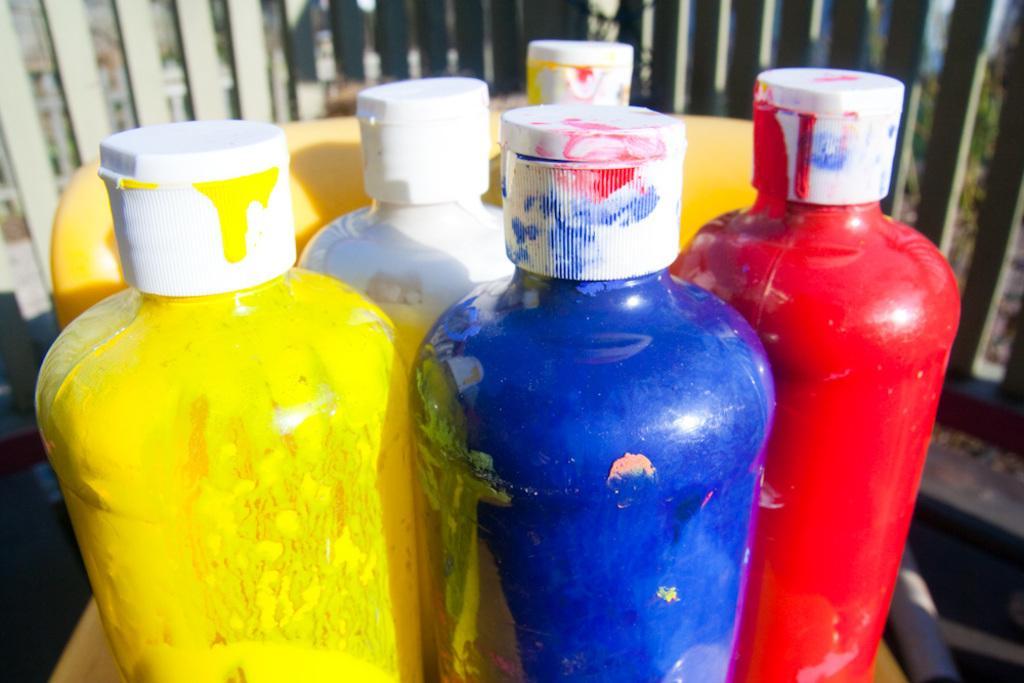In one or two sentences, can you explain what this image depicts? In the picture we can see a color bottles, with paints and white caps, in the background we can see a railing. 